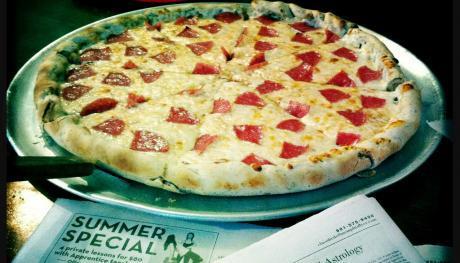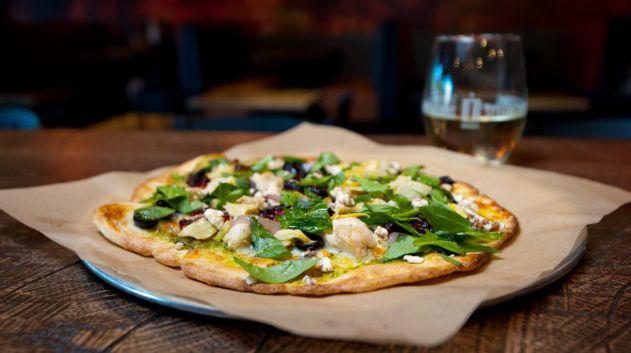The first image is the image on the left, the second image is the image on the right. Given the left and right images, does the statement "In the image on the right, there is at least one full mug of beer sitting on the table to the right of the pizza." hold true? Answer yes or no. No. 